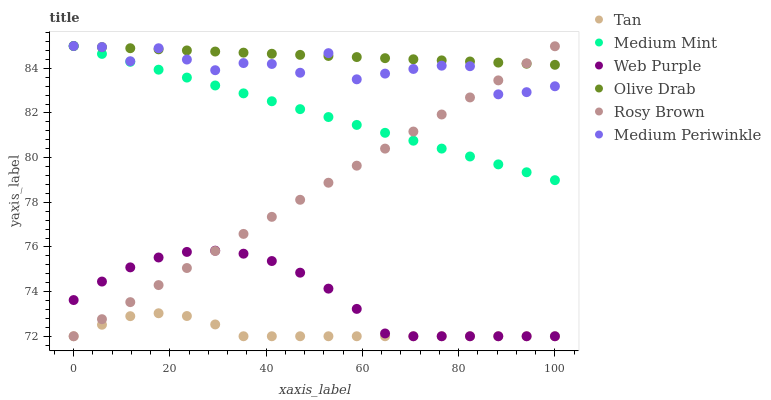Does Tan have the minimum area under the curve?
Answer yes or no. Yes. Does Olive Drab have the maximum area under the curve?
Answer yes or no. Yes. Does Rosy Brown have the minimum area under the curve?
Answer yes or no. No. Does Rosy Brown have the maximum area under the curve?
Answer yes or no. No. Is Olive Drab the smoothest?
Answer yes or no. Yes. Is Medium Periwinkle the roughest?
Answer yes or no. Yes. Is Rosy Brown the smoothest?
Answer yes or no. No. Is Rosy Brown the roughest?
Answer yes or no. No. Does Rosy Brown have the lowest value?
Answer yes or no. Yes. Does Medium Periwinkle have the lowest value?
Answer yes or no. No. Does Olive Drab have the highest value?
Answer yes or no. Yes. Does Rosy Brown have the highest value?
Answer yes or no. No. Is Tan less than Medium Mint?
Answer yes or no. Yes. Is Olive Drab greater than Web Purple?
Answer yes or no. Yes. Does Web Purple intersect Rosy Brown?
Answer yes or no. Yes. Is Web Purple less than Rosy Brown?
Answer yes or no. No. Is Web Purple greater than Rosy Brown?
Answer yes or no. No. Does Tan intersect Medium Mint?
Answer yes or no. No. 